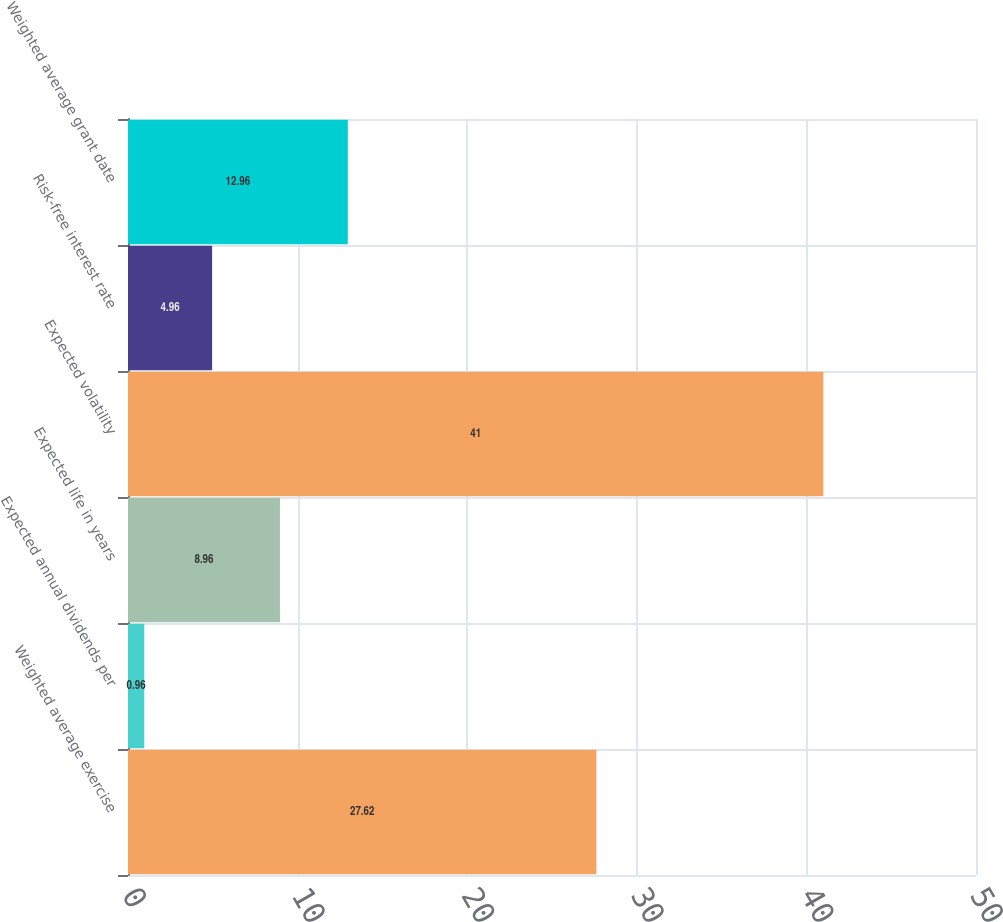Convert chart to OTSL. <chart><loc_0><loc_0><loc_500><loc_500><bar_chart><fcel>Weighted average exercise<fcel>Expected annual dividends per<fcel>Expected life in years<fcel>Expected volatility<fcel>Risk-free interest rate<fcel>Weighted average grant date<nl><fcel>27.62<fcel>0.96<fcel>8.96<fcel>41<fcel>4.96<fcel>12.96<nl></chart> 